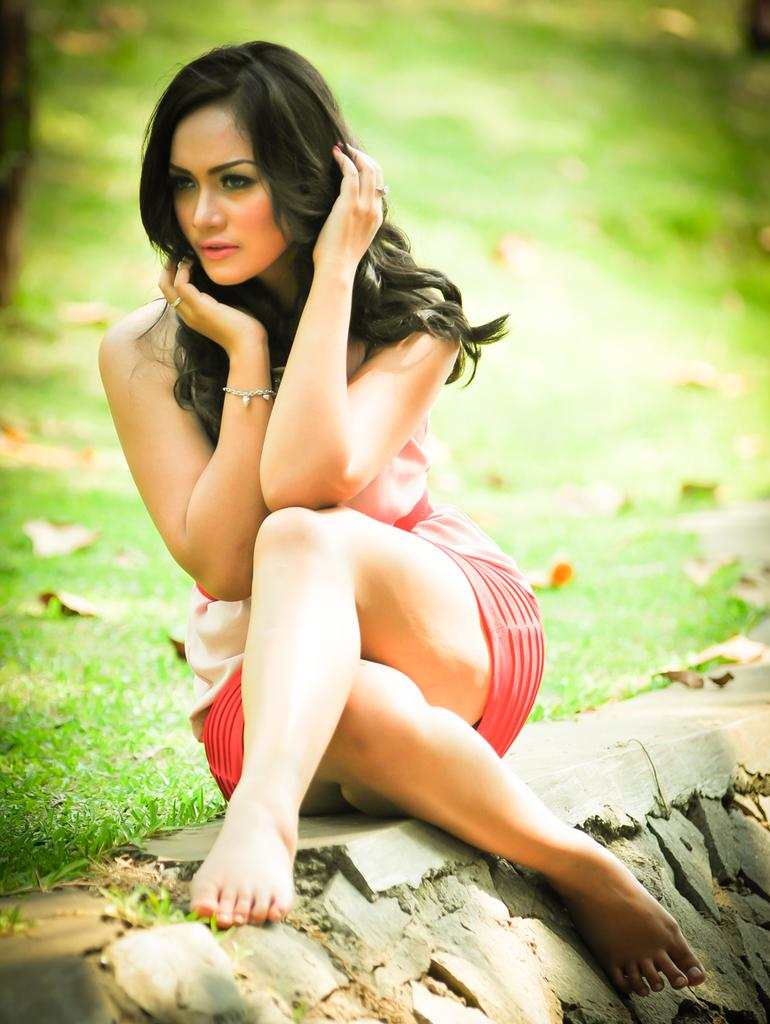Who is the main subject in the image? There is a woman in the image. What is the woman doing in the image? The woman is sitting on a surface. Can you describe the background of the image? The background of the image is blurry, and leaves and grass are visible. What type of insurance does the woman have in the image? There is no information about insurance in the image, as it focuses on the woman sitting on a surface and the background. 